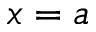<formula> <loc_0><loc_0><loc_500><loc_500>x = a</formula> 